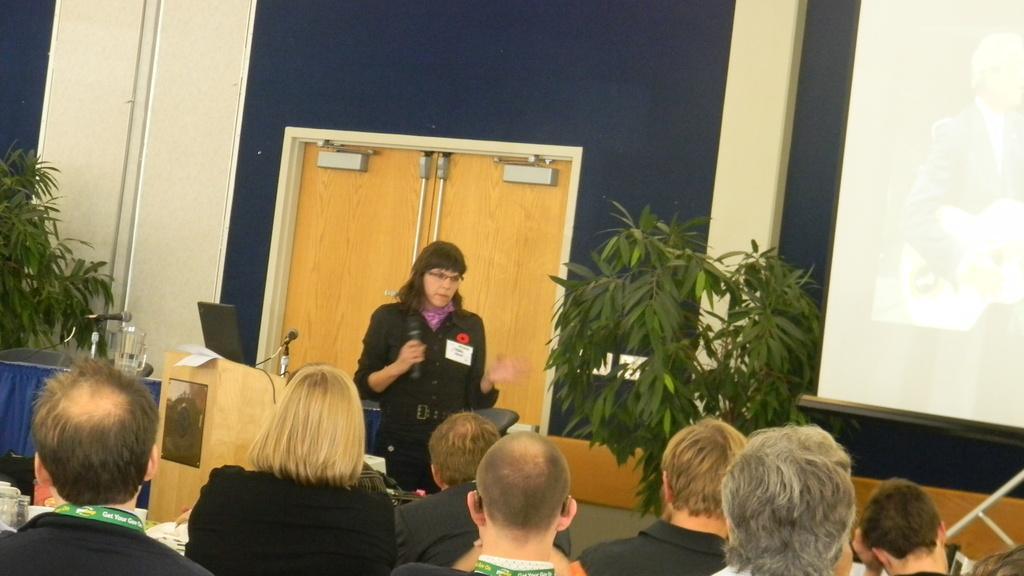Can you describe this image briefly? In this image we can see a woman standing holding a mic. We can also see a speaker stand beside her containing a laptop and some papers on it. We can also see some chairs and a table containing a jar and some miles on it. On the bottom of the image we can see a group of people sitting. On the backside we can see some plants, a door, a wall and a display screen. 